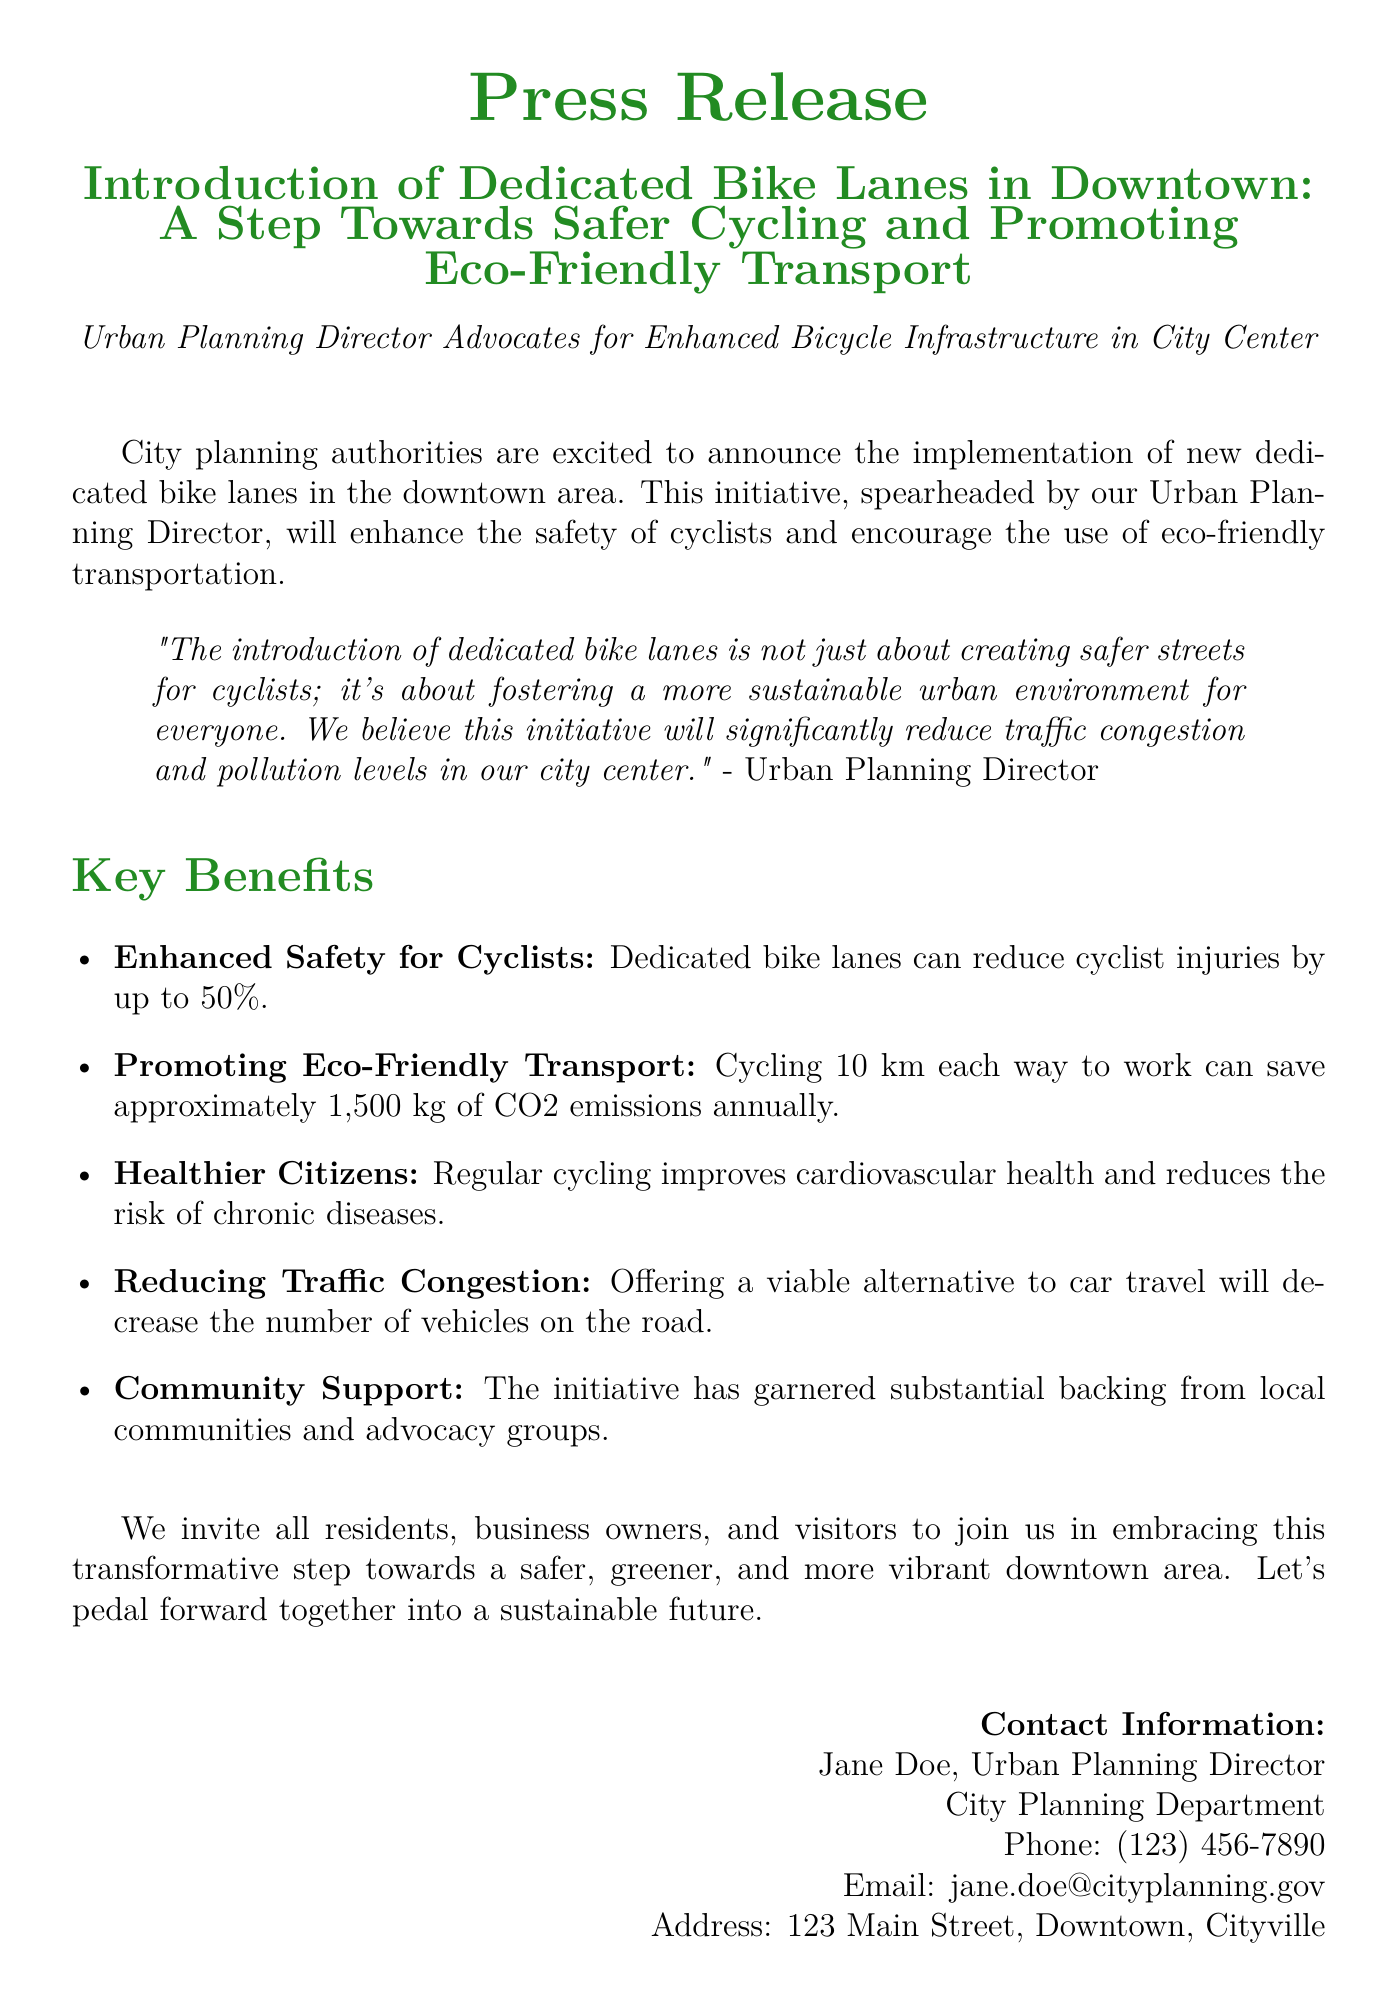What is the initiative announced in the press release? The press release announces the implementation of new dedicated bike lanes in the downtown area.
Answer: Dedicated bike lanes Who is the Urban Planning Director mentioned in the document? The press release includes the Urban Planning Director as a spokesperson but does not provide a name.
Answer: Jane Doe By what percentage can dedicated bike lanes reduce cyclist injuries? The document states that dedicated bike lanes can reduce cyclist injuries by up to 50%.
Answer: 50% What is the annual CO2 emissions savings from cycling 10 km each way to work? The document states that cycling 10 km each way to work can save approximately 1,500 kg of CO2 emissions annually.
Answer: 1,500 kg What is a benefit of cycling mentioned related to health? The document mentions that regular cycling improves cardiovascular health and reduces the risk of chronic diseases.
Answer: Cardiovascular health What is the contact phone number for the Urban Planning Director? The document provides contact information, including a phone number.
Answer: (123) 456-7890 What does the Urban Planning Director believe the initiative will help reduce? The director believes this initiative will significantly reduce traffic congestion and pollution levels.
Answer: Traffic congestion and pollution levels Which groups have shown substantial backing for the initiative? The document mentions that the initiative has garnered substantial backing from local communities and advocacy groups.
Answer: Local communities and advocacy groups 